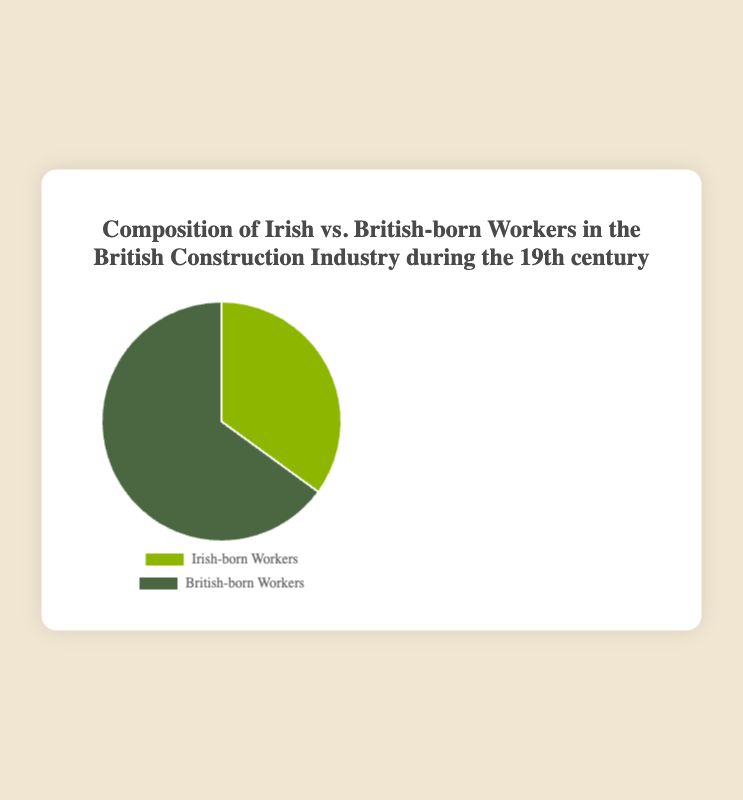What percentage of the construction workers were Irish-born? The pie chart indicates that 35% of the construction workers were Irish-born.
Answer: 35% What is the ratio of British-born to Irish-born workers in the construction industry? The pie chart indicates that the composition of British-born workers is 65% and Irish-born workers is 35%. To get the ratio of British-born to Irish-born workers, we divide 65 by 35.
Answer: 65:35 or approximately 1.86:1 If there were a total of 200 construction workers, how many were British-born? Knowing that 65% of the workers were British-born, we calculate 65% of 200. This is \( 200 \times 0.65 = 130 \).
Answer: 130 If the total number of workers increased to 500, maintaining the same proportions, how many would be Irish-born? Since 35% of the workers were Irish-born, we calculate 35% of 500 which is \( 500 \times 0.35 = 175 \).
Answer: 175 What is the difference in the number of British-born and Irish-born workers if the total count is 300? First, calculate 65% of 300 for British-born workers, which is \( 300 \times 0.65 = 195 \). Then, calculate 35% of 300 for Irish-born workers, which is \( 300 \times 0.35 = 105 \). The difference is \( 195 - 105 = 90 \).
Answer: 90 Which group forms the majority in the pie chart? The percentage of British-born workers (65%) is higher than that of Irish-born workers (35%), so the British-born workers form the majority.
Answer: British-born workers How much larger is the British-born worker segment compared to the Irish-born worker segment? The British-born worker segment is 65%, while the Irish-born worker segment is 35%. The difference is \( 65 - 35 = 30 \)%.
Answer: 30% What are the colors used to represent Irish-born and British-born workers in the chart? The chart uses one color for each group: green for Irish-born workers and another shade of green for British-born workers. The exact description of colors can't be derived directly from textual data, but there is a clear distinction between the two shades.
Answer: Green for both groups, but different shades 